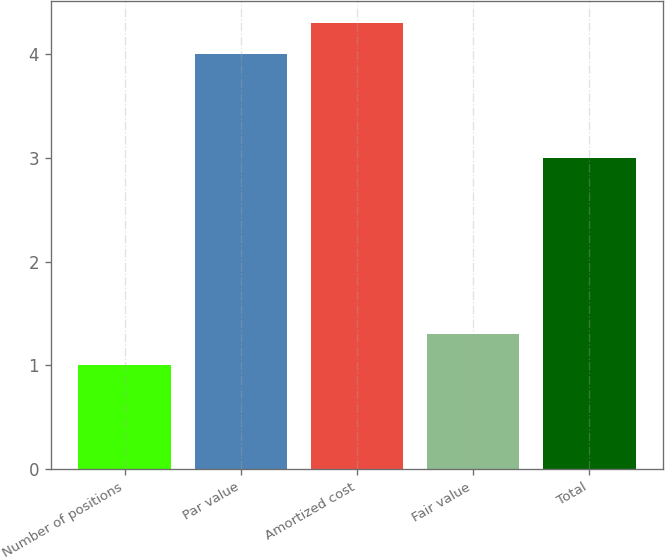<chart> <loc_0><loc_0><loc_500><loc_500><bar_chart><fcel>Number of positions<fcel>Par value<fcel>Amortized cost<fcel>Fair value<fcel>Total<nl><fcel>1<fcel>4<fcel>4.3<fcel>1.3<fcel>3<nl></chart> 